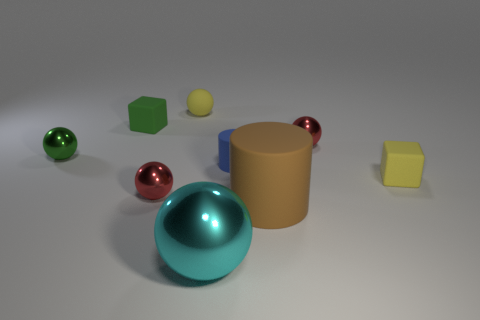Subtract all small yellow balls. How many balls are left? 4 Subtract all cyan balls. How many balls are left? 4 Subtract all purple cylinders. How many red spheres are left? 2 Subtract 1 cubes. How many cubes are left? 1 Add 7 big brown matte objects. How many big brown matte objects are left? 8 Add 8 green objects. How many green objects exist? 10 Subtract 0 blue balls. How many objects are left? 9 Subtract all cylinders. How many objects are left? 7 Subtract all blue balls. Subtract all purple cylinders. How many balls are left? 5 Subtract all big metallic objects. Subtract all tiny metal spheres. How many objects are left? 5 